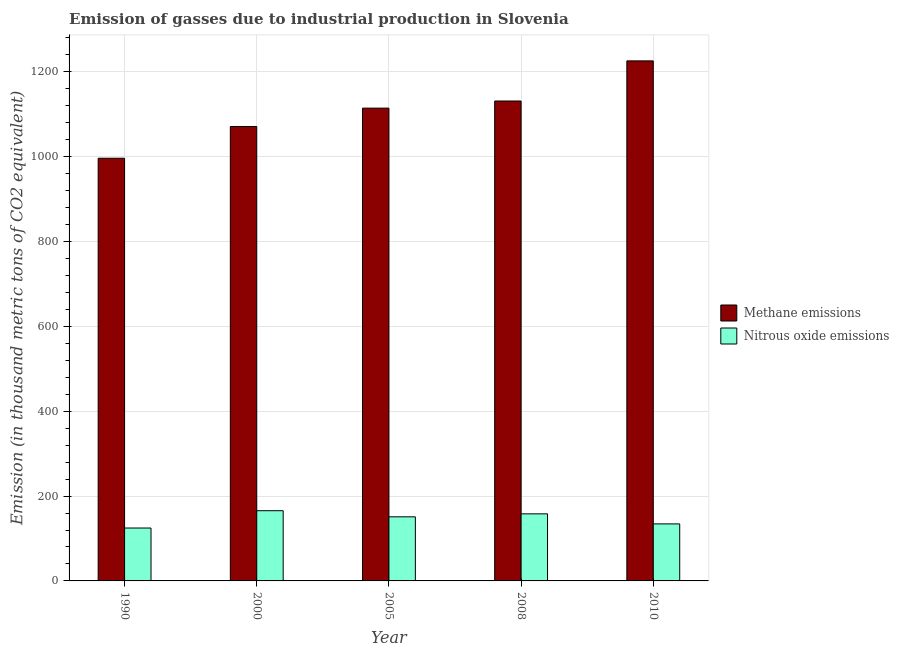How many different coloured bars are there?
Make the answer very short. 2. Are the number of bars on each tick of the X-axis equal?
Your answer should be very brief. Yes. How many bars are there on the 4th tick from the left?
Keep it short and to the point. 2. What is the label of the 1st group of bars from the left?
Offer a very short reply. 1990. In how many cases, is the number of bars for a given year not equal to the number of legend labels?
Your answer should be very brief. 0. What is the amount of nitrous oxide emissions in 2008?
Keep it short and to the point. 158.1. Across all years, what is the maximum amount of methane emissions?
Offer a very short reply. 1225.8. Across all years, what is the minimum amount of methane emissions?
Your response must be concise. 996.3. What is the total amount of methane emissions in the graph?
Ensure brevity in your answer.  5538.8. What is the difference between the amount of nitrous oxide emissions in 2000 and that in 2008?
Make the answer very short. 7.4. What is the difference between the amount of methane emissions in 2000 and the amount of nitrous oxide emissions in 2005?
Offer a very short reply. -43.3. What is the average amount of nitrous oxide emissions per year?
Ensure brevity in your answer.  146.76. In how many years, is the amount of methane emissions greater than 120 thousand metric tons?
Offer a very short reply. 5. What is the ratio of the amount of methane emissions in 2000 to that in 2010?
Provide a succinct answer. 0.87. Is the amount of methane emissions in 1990 less than that in 2005?
Keep it short and to the point. Yes. Is the difference between the amount of nitrous oxide emissions in 2000 and 2010 greater than the difference between the amount of methane emissions in 2000 and 2010?
Ensure brevity in your answer.  No. What is the difference between the highest and the second highest amount of nitrous oxide emissions?
Provide a short and direct response. 7.4. What is the difference between the highest and the lowest amount of nitrous oxide emissions?
Your answer should be very brief. 40.8. What does the 2nd bar from the left in 2000 represents?
Keep it short and to the point. Nitrous oxide emissions. What does the 2nd bar from the right in 2008 represents?
Your answer should be very brief. Methane emissions. How many bars are there?
Make the answer very short. 10. Are the values on the major ticks of Y-axis written in scientific E-notation?
Ensure brevity in your answer.  No. Does the graph contain any zero values?
Provide a succinct answer. No. Does the graph contain grids?
Your answer should be compact. Yes. How many legend labels are there?
Provide a short and direct response. 2. How are the legend labels stacked?
Provide a short and direct response. Vertical. What is the title of the graph?
Your response must be concise. Emission of gasses due to industrial production in Slovenia. Does "Borrowers" appear as one of the legend labels in the graph?
Your answer should be compact. No. What is the label or title of the X-axis?
Provide a succinct answer. Year. What is the label or title of the Y-axis?
Offer a very short reply. Emission (in thousand metric tons of CO2 equivalent). What is the Emission (in thousand metric tons of CO2 equivalent) of Methane emissions in 1990?
Provide a succinct answer. 996.3. What is the Emission (in thousand metric tons of CO2 equivalent) of Nitrous oxide emissions in 1990?
Your response must be concise. 124.7. What is the Emission (in thousand metric tons of CO2 equivalent) in Methane emissions in 2000?
Keep it short and to the point. 1071.1. What is the Emission (in thousand metric tons of CO2 equivalent) of Nitrous oxide emissions in 2000?
Offer a terse response. 165.5. What is the Emission (in thousand metric tons of CO2 equivalent) in Methane emissions in 2005?
Provide a short and direct response. 1114.4. What is the Emission (in thousand metric tons of CO2 equivalent) of Nitrous oxide emissions in 2005?
Make the answer very short. 151.1. What is the Emission (in thousand metric tons of CO2 equivalent) of Methane emissions in 2008?
Offer a very short reply. 1131.2. What is the Emission (in thousand metric tons of CO2 equivalent) in Nitrous oxide emissions in 2008?
Ensure brevity in your answer.  158.1. What is the Emission (in thousand metric tons of CO2 equivalent) of Methane emissions in 2010?
Ensure brevity in your answer.  1225.8. What is the Emission (in thousand metric tons of CO2 equivalent) of Nitrous oxide emissions in 2010?
Keep it short and to the point. 134.4. Across all years, what is the maximum Emission (in thousand metric tons of CO2 equivalent) of Methane emissions?
Provide a succinct answer. 1225.8. Across all years, what is the maximum Emission (in thousand metric tons of CO2 equivalent) of Nitrous oxide emissions?
Make the answer very short. 165.5. Across all years, what is the minimum Emission (in thousand metric tons of CO2 equivalent) of Methane emissions?
Provide a succinct answer. 996.3. Across all years, what is the minimum Emission (in thousand metric tons of CO2 equivalent) of Nitrous oxide emissions?
Your answer should be compact. 124.7. What is the total Emission (in thousand metric tons of CO2 equivalent) of Methane emissions in the graph?
Keep it short and to the point. 5538.8. What is the total Emission (in thousand metric tons of CO2 equivalent) of Nitrous oxide emissions in the graph?
Ensure brevity in your answer.  733.8. What is the difference between the Emission (in thousand metric tons of CO2 equivalent) in Methane emissions in 1990 and that in 2000?
Offer a terse response. -74.8. What is the difference between the Emission (in thousand metric tons of CO2 equivalent) of Nitrous oxide emissions in 1990 and that in 2000?
Keep it short and to the point. -40.8. What is the difference between the Emission (in thousand metric tons of CO2 equivalent) of Methane emissions in 1990 and that in 2005?
Provide a short and direct response. -118.1. What is the difference between the Emission (in thousand metric tons of CO2 equivalent) in Nitrous oxide emissions in 1990 and that in 2005?
Provide a succinct answer. -26.4. What is the difference between the Emission (in thousand metric tons of CO2 equivalent) of Methane emissions in 1990 and that in 2008?
Give a very brief answer. -134.9. What is the difference between the Emission (in thousand metric tons of CO2 equivalent) of Nitrous oxide emissions in 1990 and that in 2008?
Your answer should be compact. -33.4. What is the difference between the Emission (in thousand metric tons of CO2 equivalent) in Methane emissions in 1990 and that in 2010?
Provide a short and direct response. -229.5. What is the difference between the Emission (in thousand metric tons of CO2 equivalent) of Methane emissions in 2000 and that in 2005?
Offer a terse response. -43.3. What is the difference between the Emission (in thousand metric tons of CO2 equivalent) of Methane emissions in 2000 and that in 2008?
Ensure brevity in your answer.  -60.1. What is the difference between the Emission (in thousand metric tons of CO2 equivalent) of Methane emissions in 2000 and that in 2010?
Keep it short and to the point. -154.7. What is the difference between the Emission (in thousand metric tons of CO2 equivalent) in Nitrous oxide emissions in 2000 and that in 2010?
Offer a very short reply. 31.1. What is the difference between the Emission (in thousand metric tons of CO2 equivalent) of Methane emissions in 2005 and that in 2008?
Give a very brief answer. -16.8. What is the difference between the Emission (in thousand metric tons of CO2 equivalent) of Methane emissions in 2005 and that in 2010?
Offer a terse response. -111.4. What is the difference between the Emission (in thousand metric tons of CO2 equivalent) of Methane emissions in 2008 and that in 2010?
Keep it short and to the point. -94.6. What is the difference between the Emission (in thousand metric tons of CO2 equivalent) of Nitrous oxide emissions in 2008 and that in 2010?
Your response must be concise. 23.7. What is the difference between the Emission (in thousand metric tons of CO2 equivalent) in Methane emissions in 1990 and the Emission (in thousand metric tons of CO2 equivalent) in Nitrous oxide emissions in 2000?
Provide a succinct answer. 830.8. What is the difference between the Emission (in thousand metric tons of CO2 equivalent) of Methane emissions in 1990 and the Emission (in thousand metric tons of CO2 equivalent) of Nitrous oxide emissions in 2005?
Your answer should be compact. 845.2. What is the difference between the Emission (in thousand metric tons of CO2 equivalent) of Methane emissions in 1990 and the Emission (in thousand metric tons of CO2 equivalent) of Nitrous oxide emissions in 2008?
Give a very brief answer. 838.2. What is the difference between the Emission (in thousand metric tons of CO2 equivalent) in Methane emissions in 1990 and the Emission (in thousand metric tons of CO2 equivalent) in Nitrous oxide emissions in 2010?
Ensure brevity in your answer.  861.9. What is the difference between the Emission (in thousand metric tons of CO2 equivalent) in Methane emissions in 2000 and the Emission (in thousand metric tons of CO2 equivalent) in Nitrous oxide emissions in 2005?
Give a very brief answer. 920. What is the difference between the Emission (in thousand metric tons of CO2 equivalent) in Methane emissions in 2000 and the Emission (in thousand metric tons of CO2 equivalent) in Nitrous oxide emissions in 2008?
Provide a short and direct response. 913. What is the difference between the Emission (in thousand metric tons of CO2 equivalent) of Methane emissions in 2000 and the Emission (in thousand metric tons of CO2 equivalent) of Nitrous oxide emissions in 2010?
Your response must be concise. 936.7. What is the difference between the Emission (in thousand metric tons of CO2 equivalent) of Methane emissions in 2005 and the Emission (in thousand metric tons of CO2 equivalent) of Nitrous oxide emissions in 2008?
Your answer should be compact. 956.3. What is the difference between the Emission (in thousand metric tons of CO2 equivalent) in Methane emissions in 2005 and the Emission (in thousand metric tons of CO2 equivalent) in Nitrous oxide emissions in 2010?
Make the answer very short. 980. What is the difference between the Emission (in thousand metric tons of CO2 equivalent) in Methane emissions in 2008 and the Emission (in thousand metric tons of CO2 equivalent) in Nitrous oxide emissions in 2010?
Give a very brief answer. 996.8. What is the average Emission (in thousand metric tons of CO2 equivalent) of Methane emissions per year?
Offer a terse response. 1107.76. What is the average Emission (in thousand metric tons of CO2 equivalent) in Nitrous oxide emissions per year?
Provide a succinct answer. 146.76. In the year 1990, what is the difference between the Emission (in thousand metric tons of CO2 equivalent) of Methane emissions and Emission (in thousand metric tons of CO2 equivalent) of Nitrous oxide emissions?
Give a very brief answer. 871.6. In the year 2000, what is the difference between the Emission (in thousand metric tons of CO2 equivalent) in Methane emissions and Emission (in thousand metric tons of CO2 equivalent) in Nitrous oxide emissions?
Give a very brief answer. 905.6. In the year 2005, what is the difference between the Emission (in thousand metric tons of CO2 equivalent) of Methane emissions and Emission (in thousand metric tons of CO2 equivalent) of Nitrous oxide emissions?
Your answer should be compact. 963.3. In the year 2008, what is the difference between the Emission (in thousand metric tons of CO2 equivalent) of Methane emissions and Emission (in thousand metric tons of CO2 equivalent) of Nitrous oxide emissions?
Offer a very short reply. 973.1. In the year 2010, what is the difference between the Emission (in thousand metric tons of CO2 equivalent) of Methane emissions and Emission (in thousand metric tons of CO2 equivalent) of Nitrous oxide emissions?
Your answer should be very brief. 1091.4. What is the ratio of the Emission (in thousand metric tons of CO2 equivalent) of Methane emissions in 1990 to that in 2000?
Your answer should be compact. 0.93. What is the ratio of the Emission (in thousand metric tons of CO2 equivalent) in Nitrous oxide emissions in 1990 to that in 2000?
Offer a very short reply. 0.75. What is the ratio of the Emission (in thousand metric tons of CO2 equivalent) of Methane emissions in 1990 to that in 2005?
Offer a terse response. 0.89. What is the ratio of the Emission (in thousand metric tons of CO2 equivalent) in Nitrous oxide emissions in 1990 to that in 2005?
Your answer should be compact. 0.83. What is the ratio of the Emission (in thousand metric tons of CO2 equivalent) of Methane emissions in 1990 to that in 2008?
Keep it short and to the point. 0.88. What is the ratio of the Emission (in thousand metric tons of CO2 equivalent) in Nitrous oxide emissions in 1990 to that in 2008?
Your response must be concise. 0.79. What is the ratio of the Emission (in thousand metric tons of CO2 equivalent) in Methane emissions in 1990 to that in 2010?
Ensure brevity in your answer.  0.81. What is the ratio of the Emission (in thousand metric tons of CO2 equivalent) in Nitrous oxide emissions in 1990 to that in 2010?
Ensure brevity in your answer.  0.93. What is the ratio of the Emission (in thousand metric tons of CO2 equivalent) of Methane emissions in 2000 to that in 2005?
Provide a short and direct response. 0.96. What is the ratio of the Emission (in thousand metric tons of CO2 equivalent) in Nitrous oxide emissions in 2000 to that in 2005?
Keep it short and to the point. 1.1. What is the ratio of the Emission (in thousand metric tons of CO2 equivalent) in Methane emissions in 2000 to that in 2008?
Your answer should be compact. 0.95. What is the ratio of the Emission (in thousand metric tons of CO2 equivalent) in Nitrous oxide emissions in 2000 to that in 2008?
Offer a terse response. 1.05. What is the ratio of the Emission (in thousand metric tons of CO2 equivalent) in Methane emissions in 2000 to that in 2010?
Keep it short and to the point. 0.87. What is the ratio of the Emission (in thousand metric tons of CO2 equivalent) of Nitrous oxide emissions in 2000 to that in 2010?
Your answer should be very brief. 1.23. What is the ratio of the Emission (in thousand metric tons of CO2 equivalent) of Methane emissions in 2005 to that in 2008?
Your answer should be compact. 0.99. What is the ratio of the Emission (in thousand metric tons of CO2 equivalent) in Nitrous oxide emissions in 2005 to that in 2008?
Offer a very short reply. 0.96. What is the ratio of the Emission (in thousand metric tons of CO2 equivalent) of Nitrous oxide emissions in 2005 to that in 2010?
Give a very brief answer. 1.12. What is the ratio of the Emission (in thousand metric tons of CO2 equivalent) of Methane emissions in 2008 to that in 2010?
Provide a succinct answer. 0.92. What is the ratio of the Emission (in thousand metric tons of CO2 equivalent) in Nitrous oxide emissions in 2008 to that in 2010?
Your answer should be very brief. 1.18. What is the difference between the highest and the second highest Emission (in thousand metric tons of CO2 equivalent) of Methane emissions?
Provide a succinct answer. 94.6. What is the difference between the highest and the lowest Emission (in thousand metric tons of CO2 equivalent) of Methane emissions?
Offer a very short reply. 229.5. What is the difference between the highest and the lowest Emission (in thousand metric tons of CO2 equivalent) in Nitrous oxide emissions?
Ensure brevity in your answer.  40.8. 